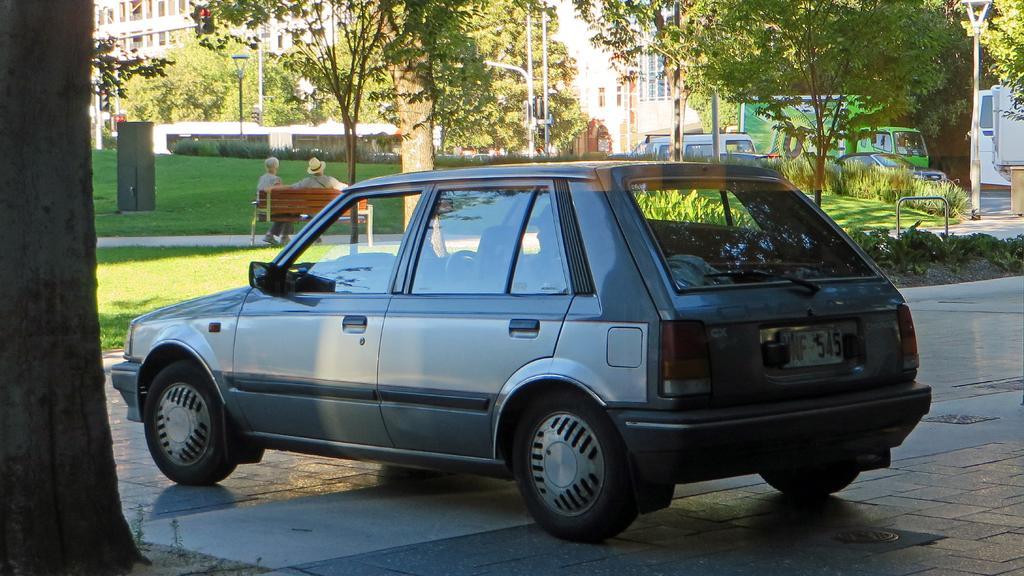How would you summarize this image in a sentence or two? In this picture I can see vehicles, grass, plants, buildings, trees, lights, poles, two persons sitting on the bench. 